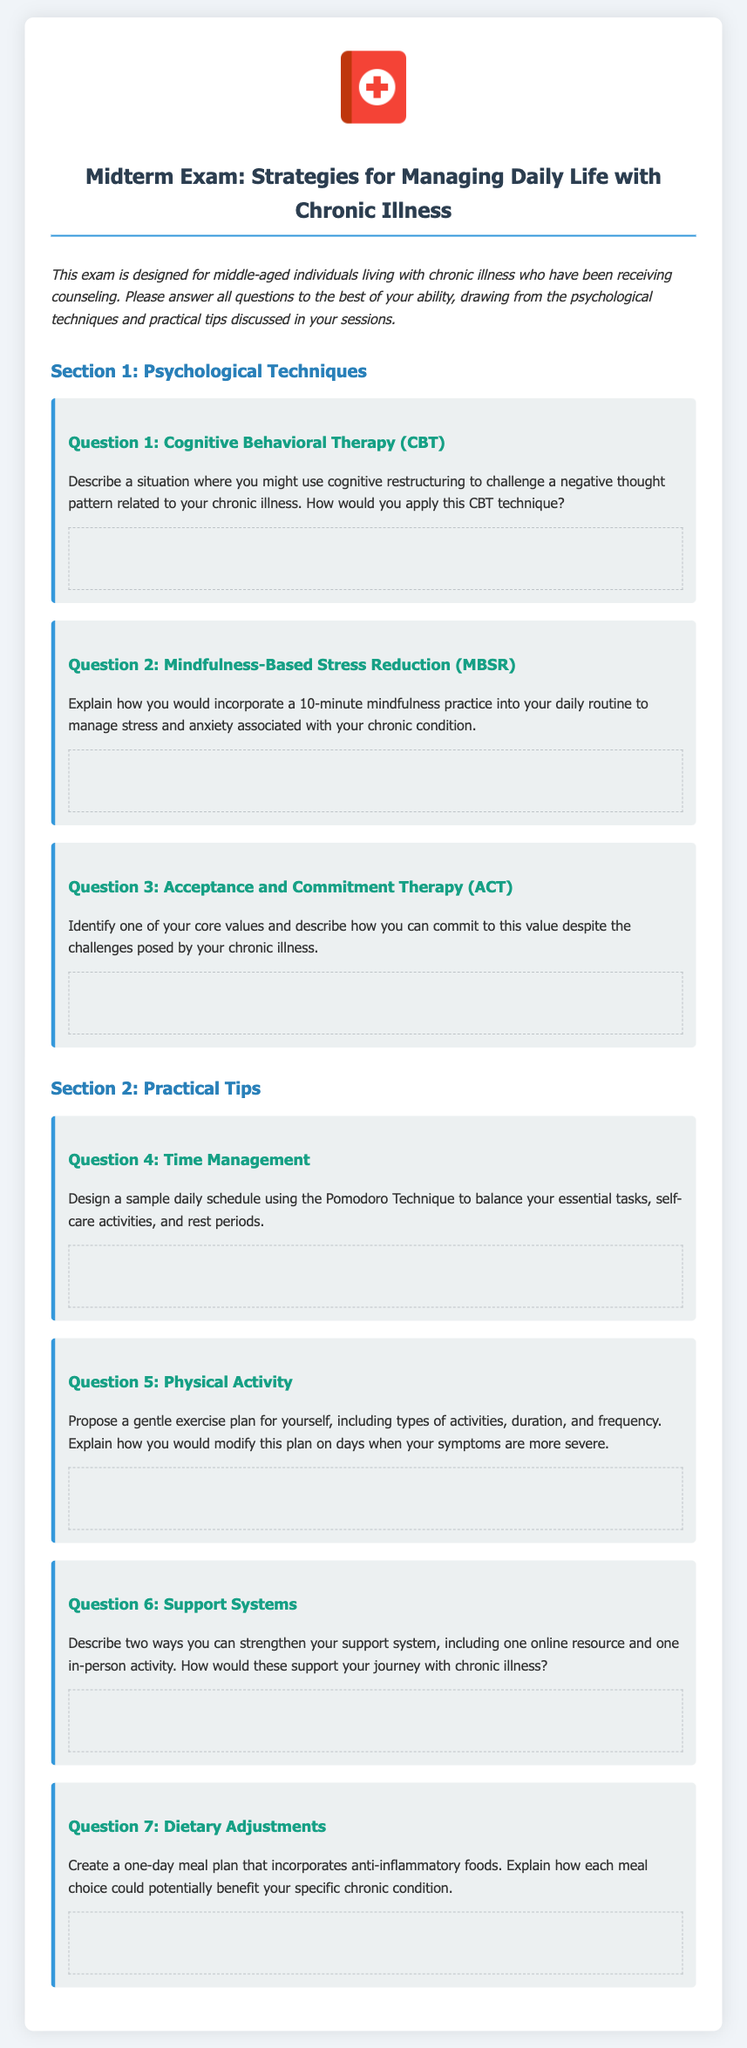What is the title of the document? The title of the document, as indicated in the header, is "Midterm Exam: Strategies for Managing Daily Life with Chronic Illness."
Answer: Midterm Exam: Strategies for Managing Daily Life with Chronic Illness How many sections does the exam have? The exam is divided into two sections: Psychological Techniques and Practical Tips.
Answer: 2 What is the focus of Section 1? Section 1 of the exam focuses on Psychological Techniques relevant to managing chronic illness.
Answer: Psychological Techniques What type of exercise plan is requested in Question 5? Question 5 asks for a gentle exercise plan that includes types of activities, duration, and frequency.
Answer: Gentle exercise plan How many core values are participants asked to identify in Question 3? Participants are asked to identify one core value in Question 3.
Answer: One What is the purpose of the document? The document is designed for middle-aged individuals living with chronic illness who have been receiving counseling.
Answer: To provide a midterm exam for individuals living with chronic illness What technique is suggested in Question 4 for time management? The Pomodoro Technique is suggested for balancing essential tasks and self-care activities in Question 4.
Answer: Pomodoro Technique What type of meal is participants asked to create in Question 7? Participants are asked to create a one-day meal plan that incorporates anti-inflammatory foods.
Answer: One-day meal plan What is the image used in the exam header? The image used in the exam header is a health book icon.
Answer: Health book icon 